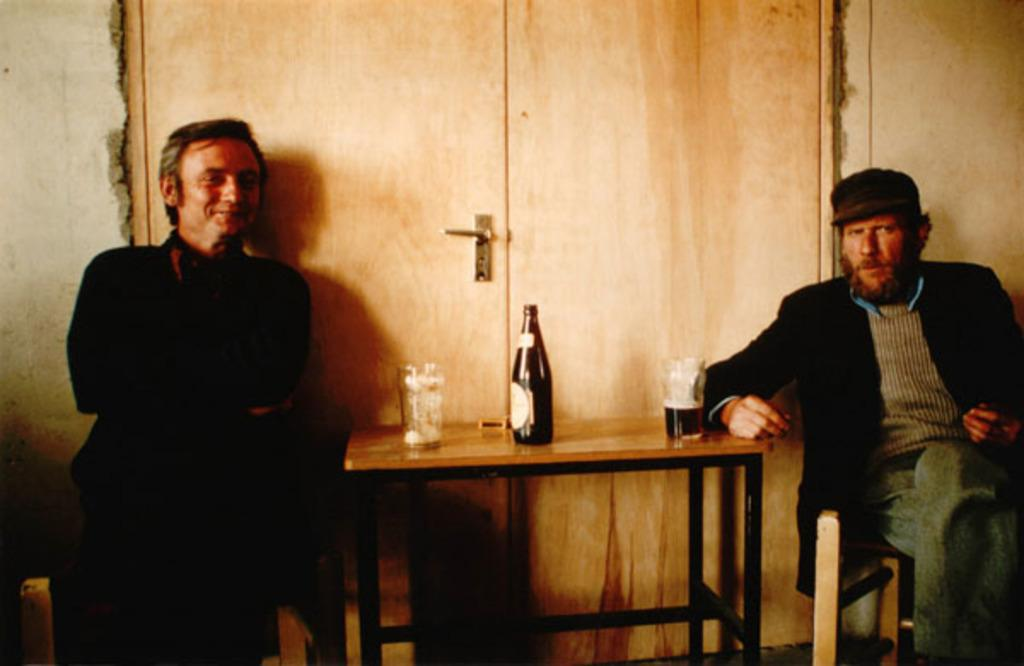What is the position of the first man in the image? There is a man sitting on a chair in the image. What is the position of the second man in the image? There is another man standing in the image. What objects are on the table in the image? There is a wine bottle and a wine glass on the table. What stage of development is the rail system in the image? There is no rail system present in the image. What type of skin condition can be seen on the man sitting on the chair? There is no indication of any skin condition on the man sitting on the chair in the image. 